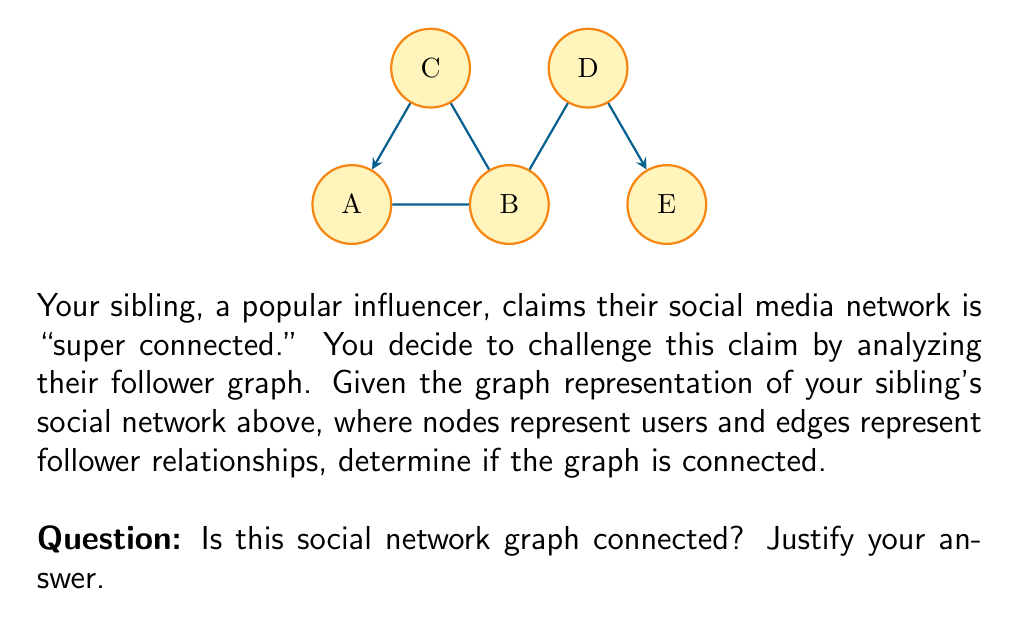Can you solve this math problem? To determine if a graph is connected, we need to check if there exists a path between any two vertices in the graph. We can do this systematically:

1) First, let's recall the definition of a connected graph:
   A graph is connected if there is a path between every pair of vertices.

2) Now, let's examine the paths from vertex A to all other vertices:
   - A to B: direct edge
   - A to C: direct edge
   - A to D: A → B → D
   - A to E: A → B → D → E

3) We can see that there is a path from A to every other vertex. However, this alone is not sufficient to prove the graph is connected.

4) To be thorough, we should check if there's a path between every pair of vertices. But due to the transitive property of connectivity, if A is connected to all vertices, then all vertices are connected to each other through A.

5) Therefore, we can conclude that there is a path between every pair of vertices in this graph.

The graph satisfies the definition of a connected graph, as there exists a path between any two vertices.
Answer: Yes, the graph is connected. 